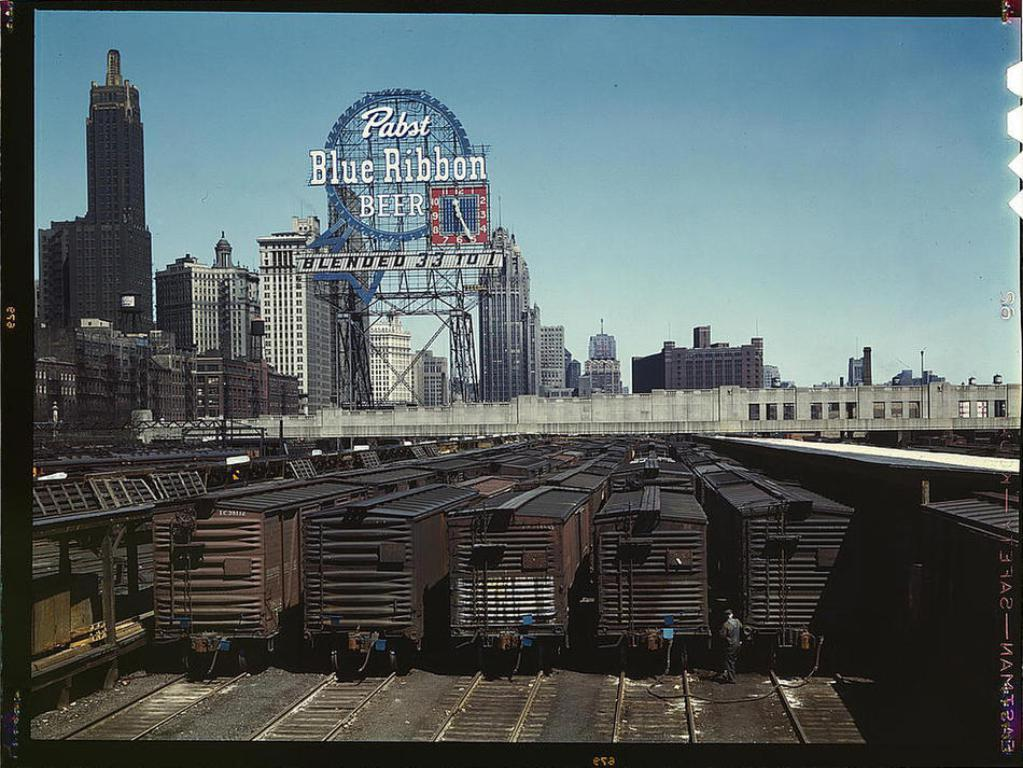What type of vehicles can be seen on the tracks in the image? There are trains on the tracks in the image. What can be seen in the distance behind the tracks? There are buildings in the background of the image. What type of pancake is being served in the image? There is no pancake present in the image; it features trains on tracks and buildings in the background. 